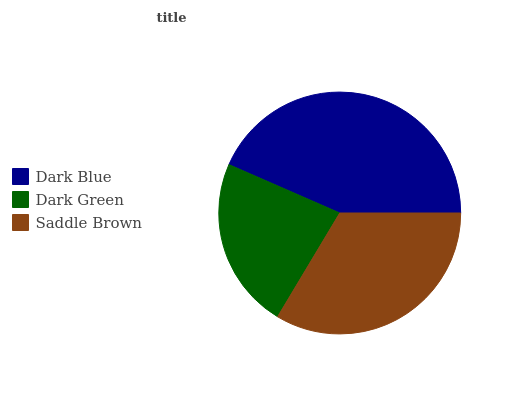Is Dark Green the minimum?
Answer yes or no. Yes. Is Dark Blue the maximum?
Answer yes or no. Yes. Is Saddle Brown the minimum?
Answer yes or no. No. Is Saddle Brown the maximum?
Answer yes or no. No. Is Saddle Brown greater than Dark Green?
Answer yes or no. Yes. Is Dark Green less than Saddle Brown?
Answer yes or no. Yes. Is Dark Green greater than Saddle Brown?
Answer yes or no. No. Is Saddle Brown less than Dark Green?
Answer yes or no. No. Is Saddle Brown the high median?
Answer yes or no. Yes. Is Saddle Brown the low median?
Answer yes or no. Yes. Is Dark Blue the high median?
Answer yes or no. No. Is Dark Green the low median?
Answer yes or no. No. 